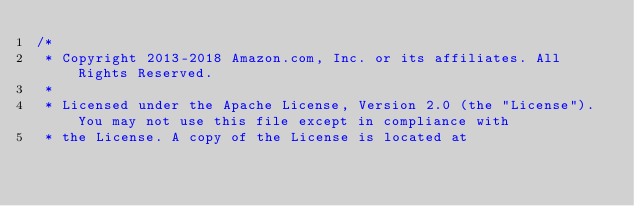<code> <loc_0><loc_0><loc_500><loc_500><_Java_>/*
 * Copyright 2013-2018 Amazon.com, Inc. or its affiliates. All Rights Reserved.
 * 
 * Licensed under the Apache License, Version 2.0 (the "License"). You may not use this file except in compliance with
 * the License. A copy of the License is located at</code> 